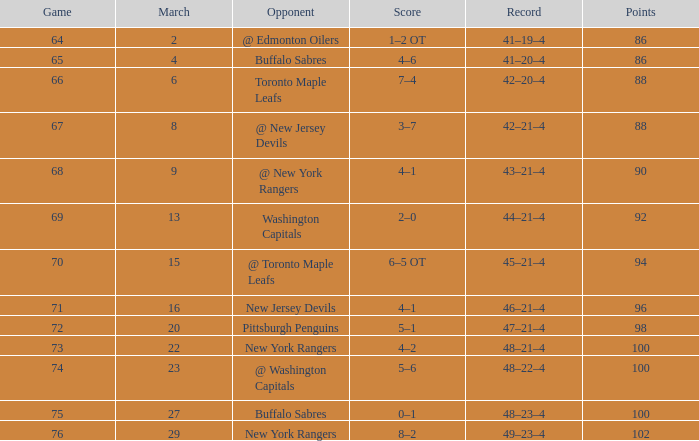Which March is the lowest one that has a Score of 5–6, and Points smaller than 100? None. 